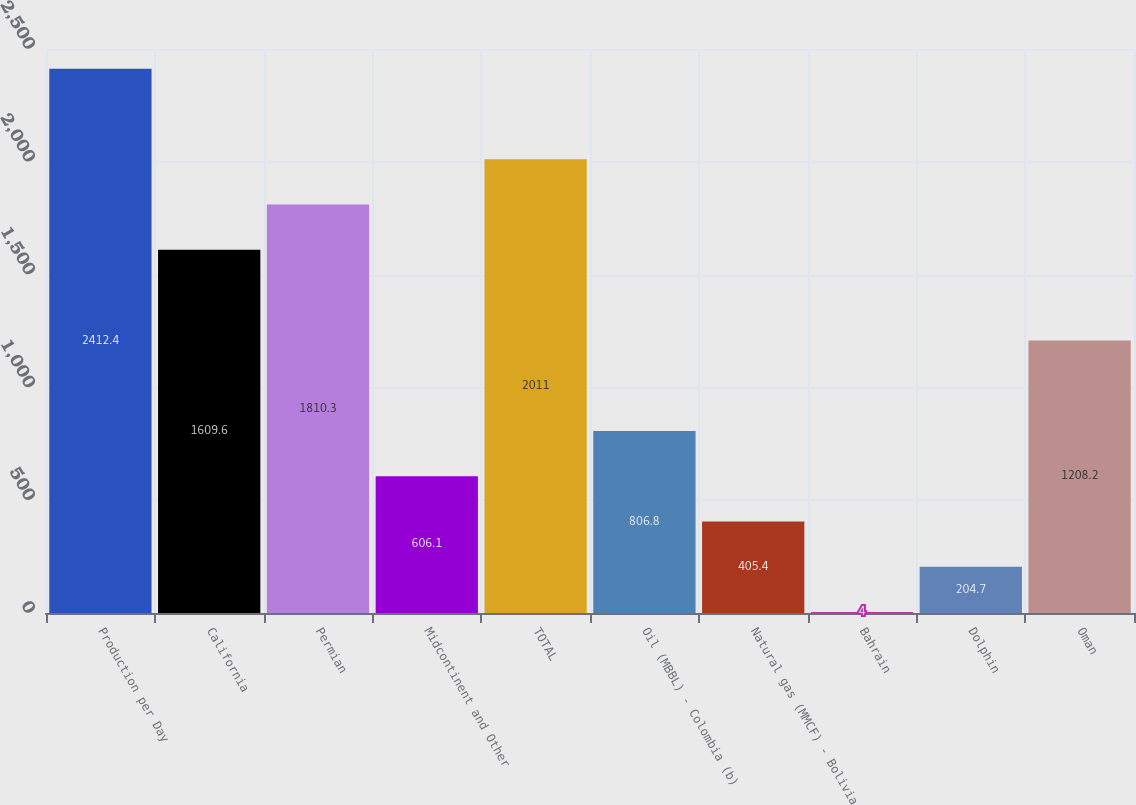<chart> <loc_0><loc_0><loc_500><loc_500><bar_chart><fcel>Production per Day<fcel>California<fcel>Permian<fcel>Midcontinent and Other<fcel>TOTAL<fcel>Oil (MBBL) - Colombia (b)<fcel>Natural gas (MMCF) - Bolivia<fcel>Bahrain<fcel>Dolphin<fcel>Oman<nl><fcel>2412.4<fcel>1609.6<fcel>1810.3<fcel>606.1<fcel>2011<fcel>806.8<fcel>405.4<fcel>4<fcel>204.7<fcel>1208.2<nl></chart> 